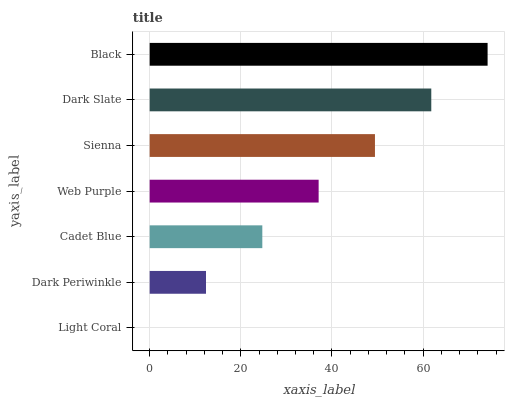Is Light Coral the minimum?
Answer yes or no. Yes. Is Black the maximum?
Answer yes or no. Yes. Is Dark Periwinkle the minimum?
Answer yes or no. No. Is Dark Periwinkle the maximum?
Answer yes or no. No. Is Dark Periwinkle greater than Light Coral?
Answer yes or no. Yes. Is Light Coral less than Dark Periwinkle?
Answer yes or no. Yes. Is Light Coral greater than Dark Periwinkle?
Answer yes or no. No. Is Dark Periwinkle less than Light Coral?
Answer yes or no. No. Is Web Purple the high median?
Answer yes or no. Yes. Is Web Purple the low median?
Answer yes or no. Yes. Is Dark Slate the high median?
Answer yes or no. No. Is Dark Slate the low median?
Answer yes or no. No. 